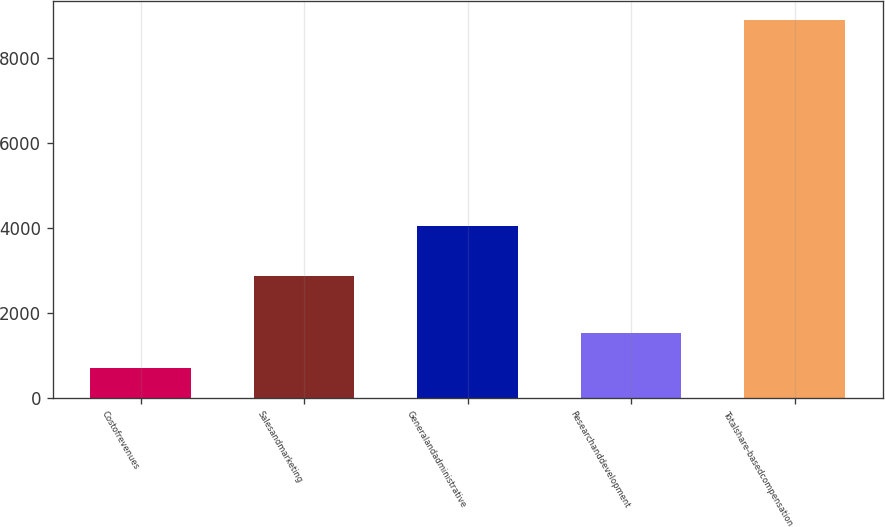<chart> <loc_0><loc_0><loc_500><loc_500><bar_chart><fcel>Costofrevenues<fcel>Salesandmarketing<fcel>Generalandadministrative<fcel>Researchanddevelopment<fcel>Totalshare-basedcompensation<nl><fcel>700<fcel>2862<fcel>4054<fcel>1521<fcel>8910<nl></chart> 